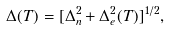Convert formula to latex. <formula><loc_0><loc_0><loc_500><loc_500>\Delta ( T ) = [ \Delta _ { n } ^ { 2 } + \Delta _ { e } ^ { 2 } ( T ) ] ^ { 1 / 2 } ,</formula> 